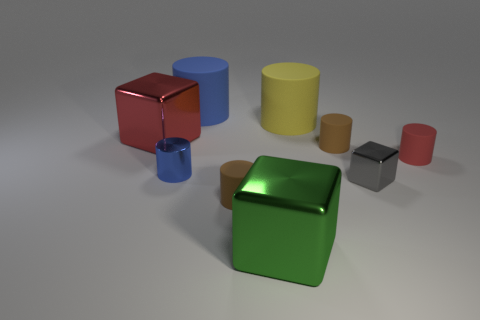How many spheres are cyan things or big blue rubber things?
Give a very brief answer. 0. Is there a brown rubber object of the same shape as the yellow thing?
Your answer should be very brief. Yes. What number of other objects are there of the same color as the tiny metal cube?
Your response must be concise. 0. Are there fewer small cylinders that are behind the big red block than small blue cylinders?
Provide a succinct answer. Yes. What number of red rubber cylinders are there?
Offer a terse response. 1. How many large cubes are the same material as the big yellow cylinder?
Give a very brief answer. 0. How many things are either gray objects right of the large green metal object or tiny green spheres?
Offer a terse response. 1. Are there fewer cylinders that are behind the large yellow object than big rubber things behind the small gray metallic object?
Your answer should be compact. Yes. There is a large green block; are there any red rubber cylinders left of it?
Provide a succinct answer. No. What number of things are small brown matte cylinders that are left of the big yellow rubber cylinder or brown things that are left of the green cube?
Keep it short and to the point. 1. 